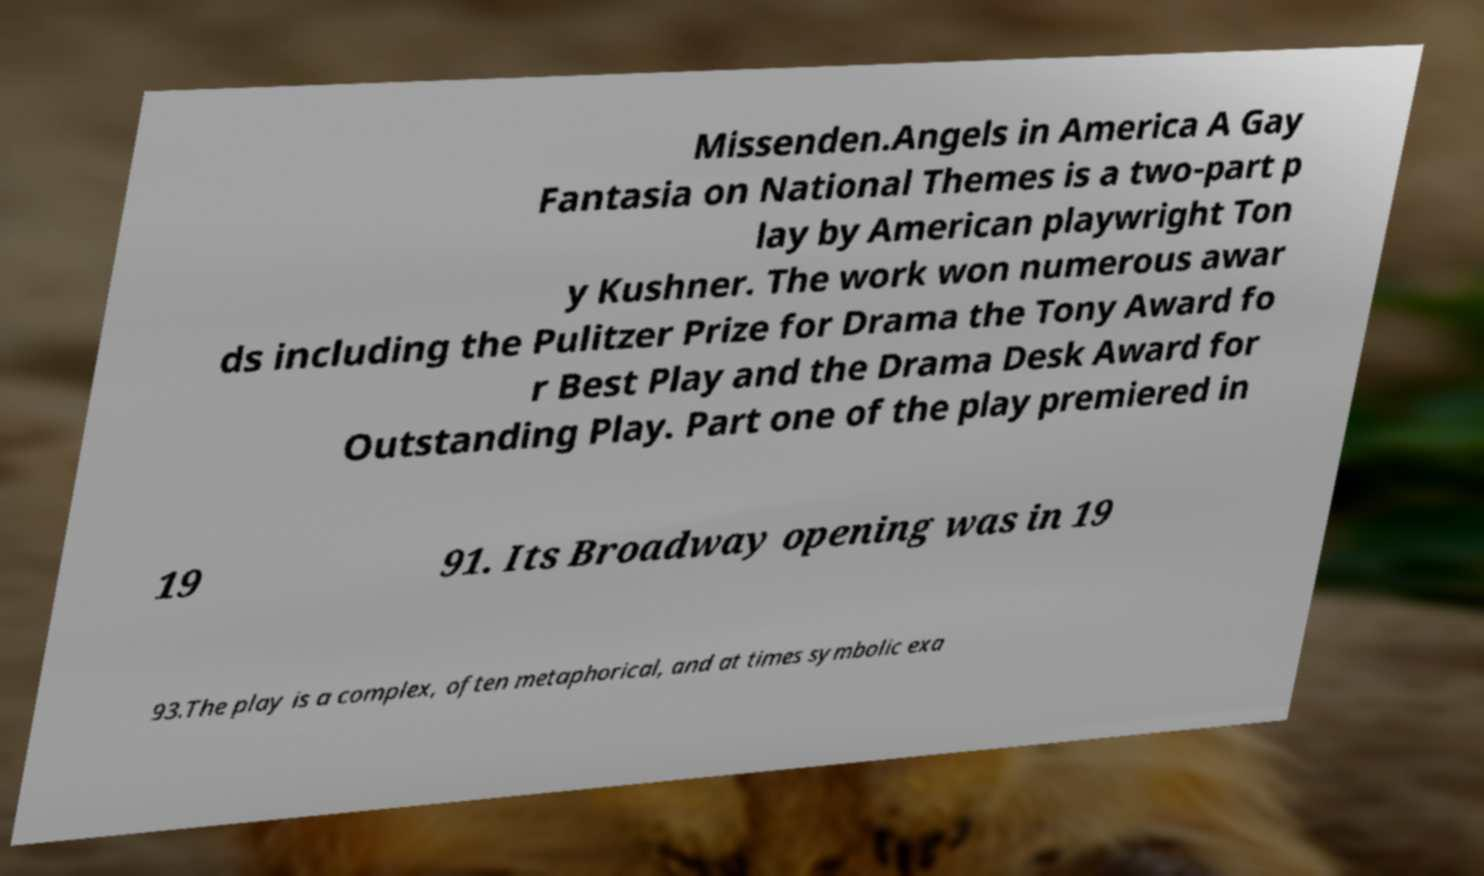I need the written content from this picture converted into text. Can you do that? Missenden.Angels in America A Gay Fantasia on National Themes is a two-part p lay by American playwright Ton y Kushner. The work won numerous awar ds including the Pulitzer Prize for Drama the Tony Award fo r Best Play and the Drama Desk Award for Outstanding Play. Part one of the play premiered in 19 91. Its Broadway opening was in 19 93.The play is a complex, often metaphorical, and at times symbolic exa 